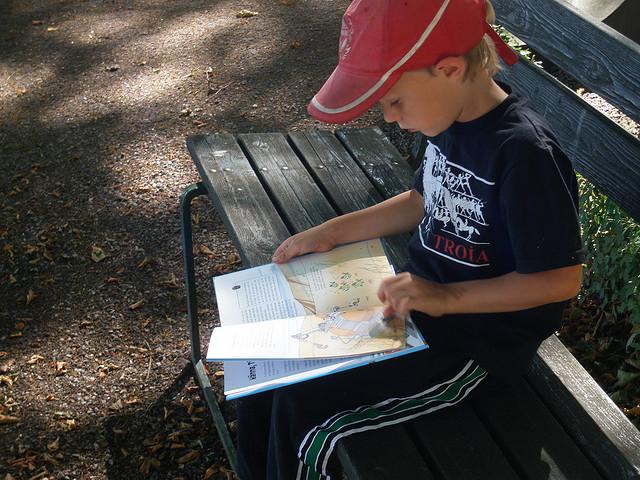Who is sitting on the bench?
Be succinct. Boy. What is this boy doing?
Give a very brief answer. Reading. How many slats are on the bench?
Short answer required. 4. 